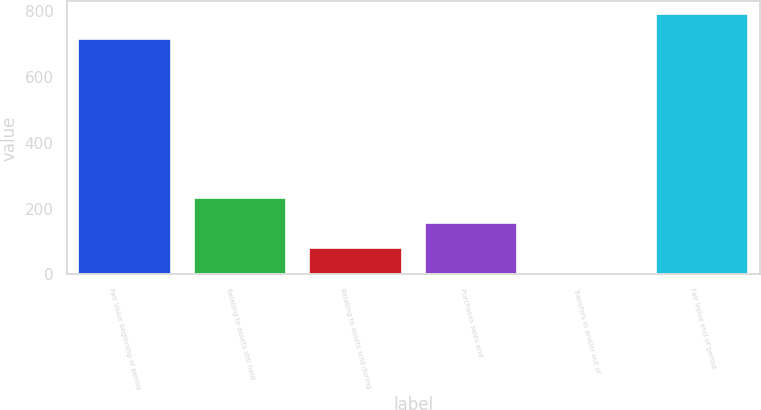Convert chart. <chart><loc_0><loc_0><loc_500><loc_500><bar_chart><fcel>Fair Value beginning of period<fcel>Relating to assets still held<fcel>Relating to assets sold during<fcel>Purchases sales and<fcel>Transfers in and/or out of<fcel>Fair Value end of period<nl><fcel>714<fcel>230.82<fcel>79.62<fcel>155.22<fcel>4.02<fcel>789.6<nl></chart> 